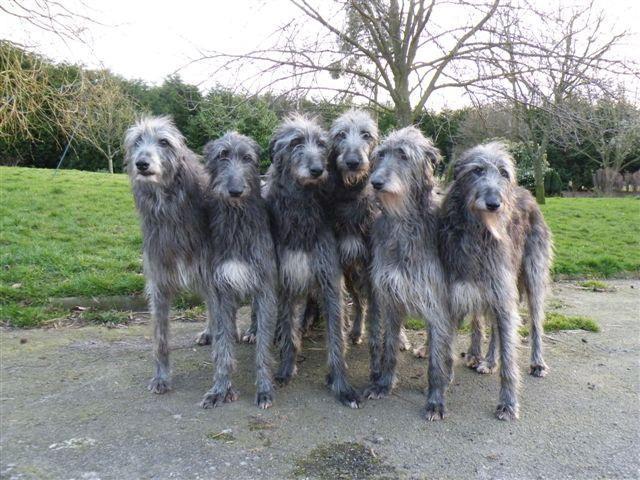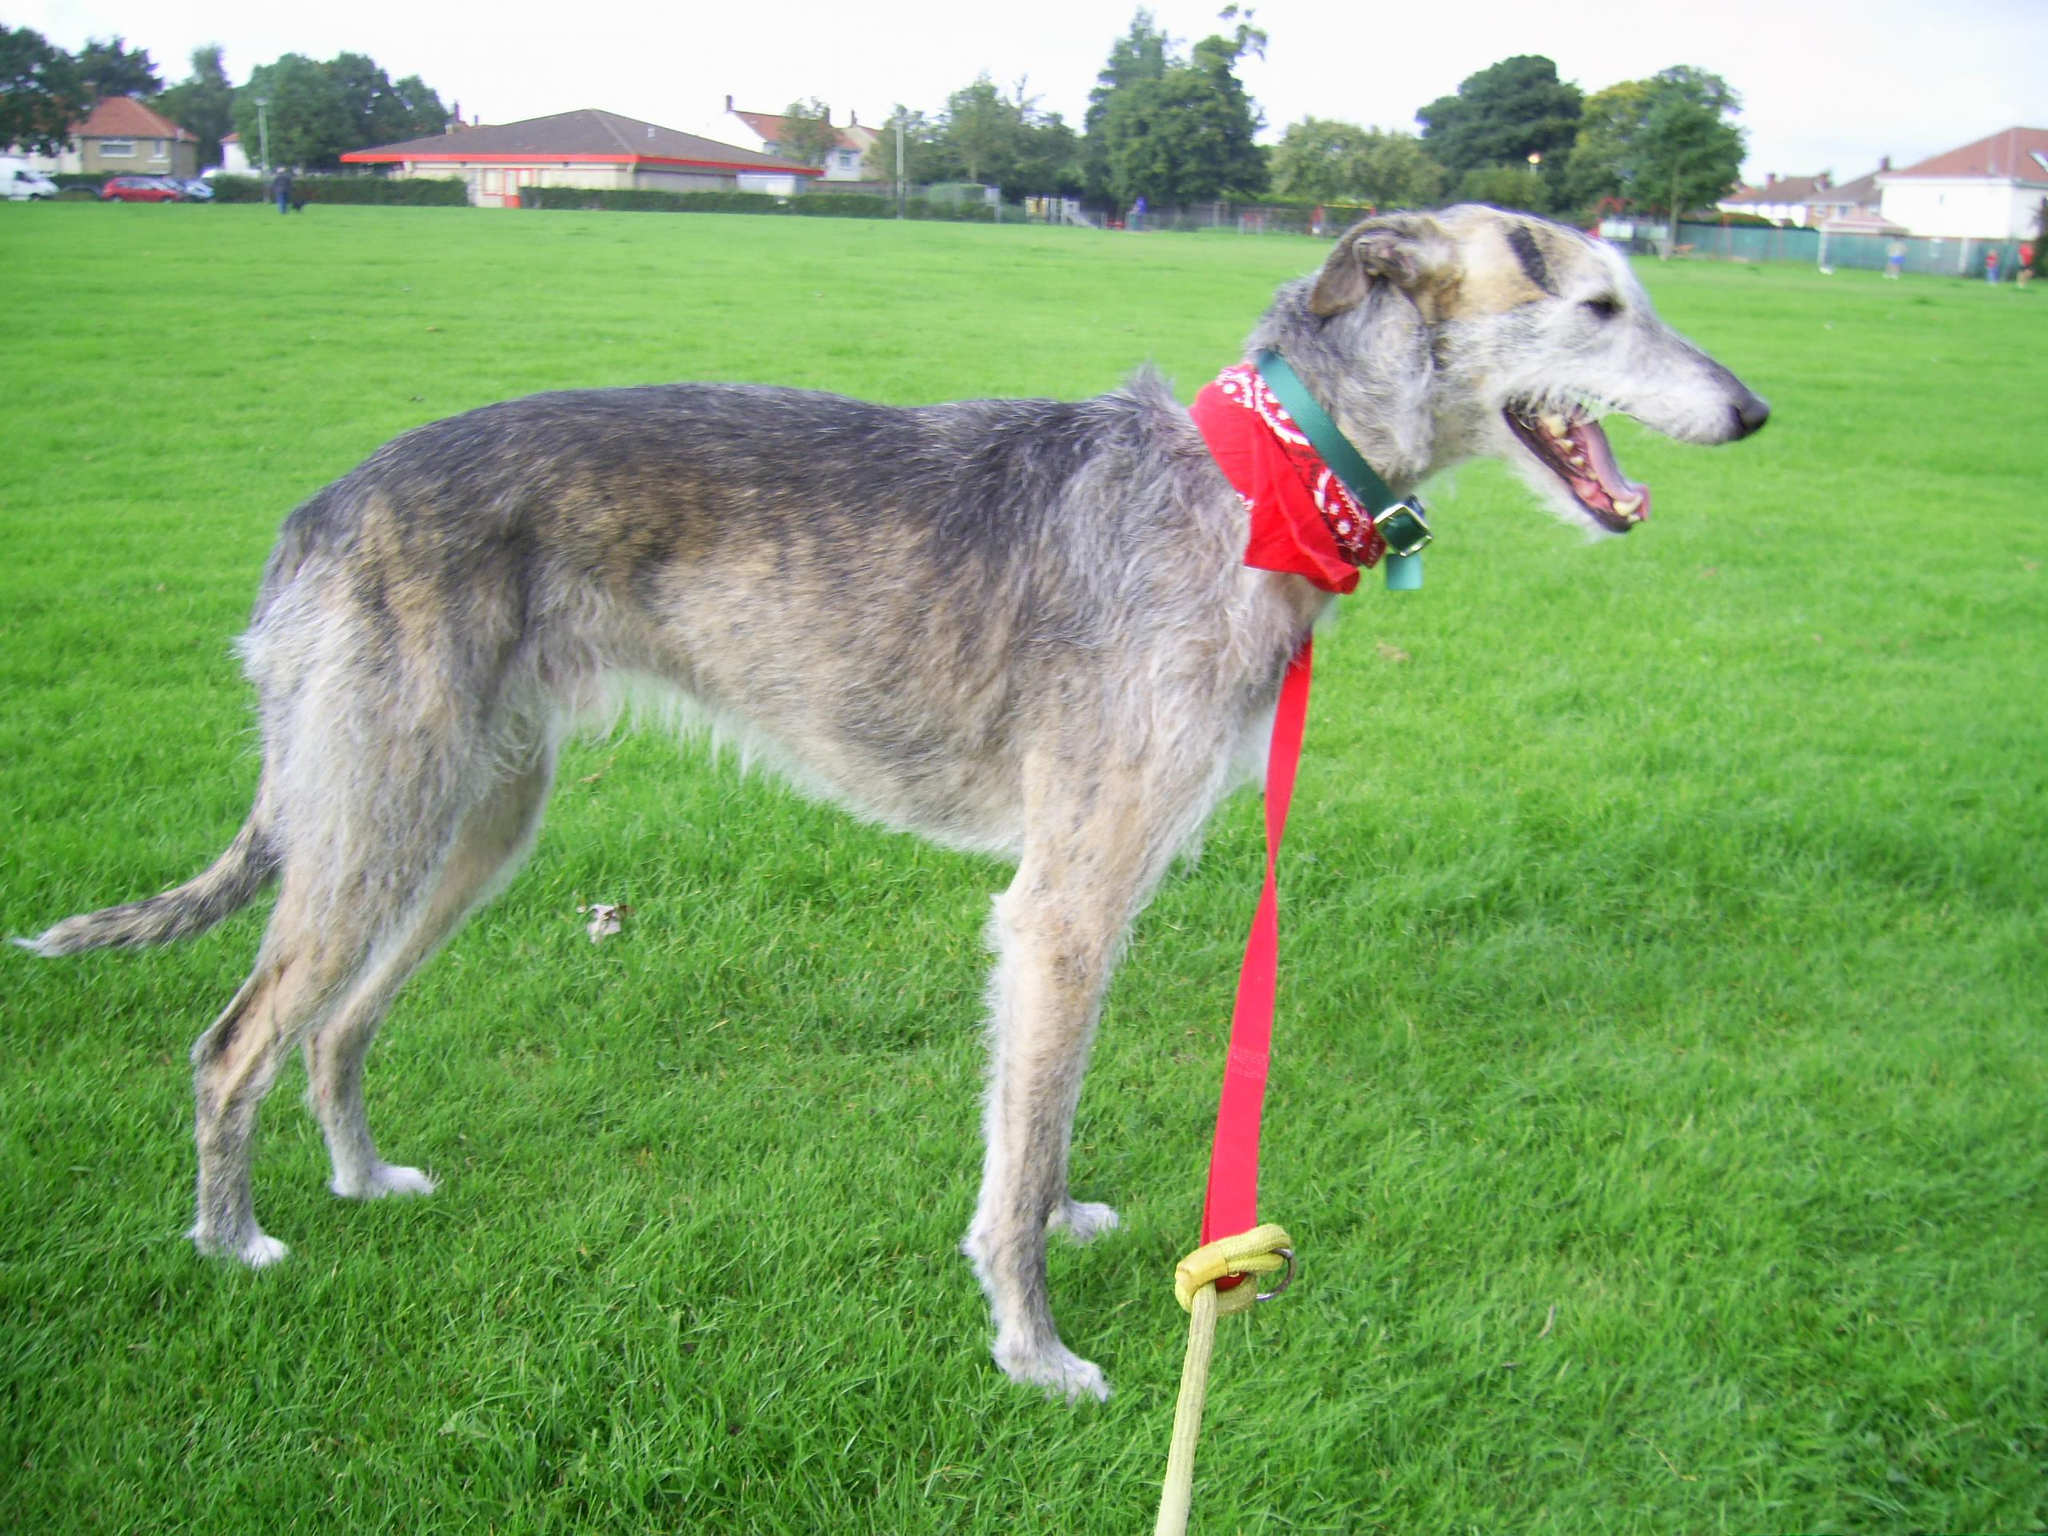The first image is the image on the left, the second image is the image on the right. Examine the images to the left and right. Is the description "All hounds are standing, and one image contains one rightward facing hound on a leash." accurate? Answer yes or no. Yes. The first image is the image on the left, the second image is the image on the right. Analyze the images presented: Is the assertion "The left image contains exactly two dogs." valid? Answer yes or no. No. 